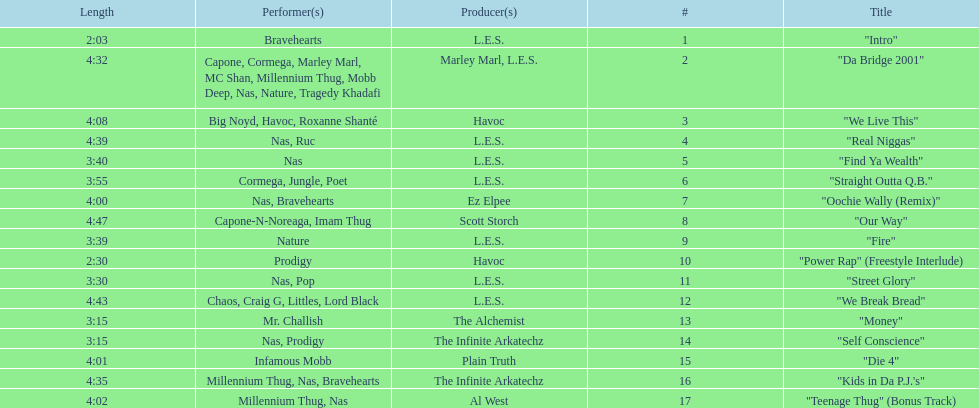How many songs were on the track list? 17. Can you parse all the data within this table? {'header': ['Length', 'Performer(s)', 'Producer(s)', '#', 'Title'], 'rows': [['2:03', 'Bravehearts', 'L.E.S.', '1', '"Intro"'], ['4:32', 'Capone, Cormega, Marley Marl, MC Shan, Millennium Thug, Mobb Deep, Nas, Nature, Tragedy Khadafi', 'Marley Marl, L.E.S.', '2', '"Da Bridge 2001"'], ['4:08', 'Big Noyd, Havoc, Roxanne Shanté', 'Havoc', '3', '"We Live This"'], ['4:39', 'Nas, Ruc', 'L.E.S.', '4', '"Real Niggas"'], ['3:40', 'Nas', 'L.E.S.', '5', '"Find Ya Wealth"'], ['3:55', 'Cormega, Jungle, Poet', 'L.E.S.', '6', '"Straight Outta Q.B."'], ['4:00', 'Nas, Bravehearts', 'Ez Elpee', '7', '"Oochie Wally (Remix)"'], ['4:47', 'Capone-N-Noreaga, Imam Thug', 'Scott Storch', '8', '"Our Way"'], ['3:39', 'Nature', 'L.E.S.', '9', '"Fire"'], ['2:30', 'Prodigy', 'Havoc', '10', '"Power Rap" (Freestyle Interlude)'], ['3:30', 'Nas, Pop', 'L.E.S.', '11', '"Street Glory"'], ['4:43', 'Chaos, Craig G, Littles, Lord Black', 'L.E.S.', '12', '"We Break Bread"'], ['3:15', 'Mr. Challish', 'The Alchemist', '13', '"Money"'], ['3:15', 'Nas, Prodigy', 'The Infinite Arkatechz', '14', '"Self Conscience"'], ['4:01', 'Infamous Mobb', 'Plain Truth', '15', '"Die 4"'], ['4:35', 'Millennium Thug, Nas, Bravehearts', 'The Infinite Arkatechz', '16', '"Kids in Da P.J.\'s"'], ['4:02', 'Millennium Thug, Nas', 'Al West', '17', '"Teenage Thug" (Bonus Track)']]} 